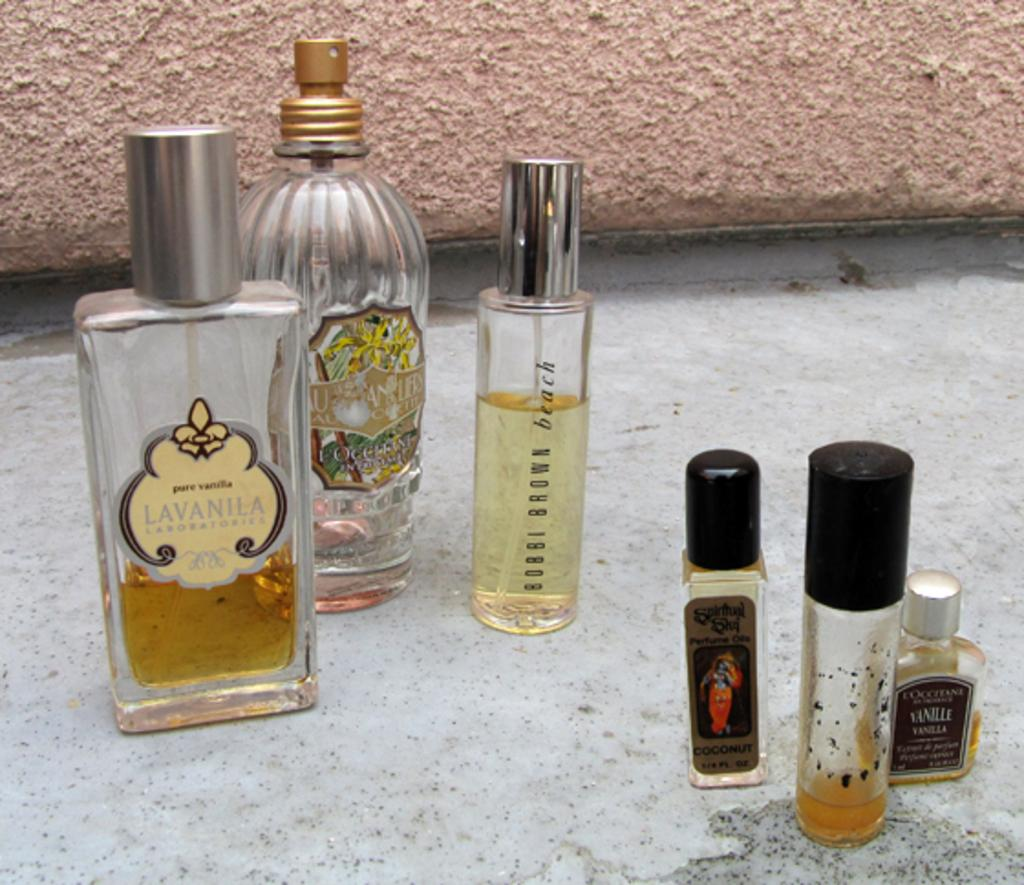<image>
Provide a brief description of the given image. some bottles of liquid that had lavanila on it 